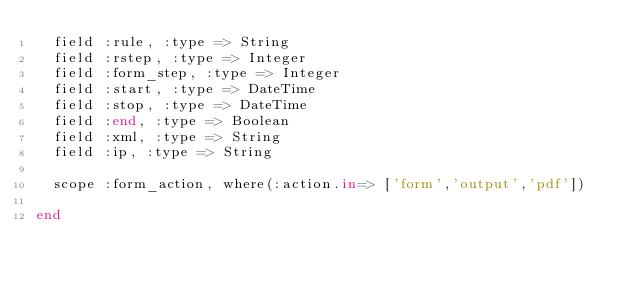Convert code to text. <code><loc_0><loc_0><loc_500><loc_500><_Ruby_>  field :rule, :type => String
  field :rstep, :type => Integer
  field :form_step, :type => Integer
  field :start, :type => DateTime
  field :stop, :type => DateTime
  field :end, :type => Boolean
  field :xml, :type => String
  field :ip, :type => String

  scope :form_action, where(:action.in=> ['form','output','pdf'])

end
</code> 